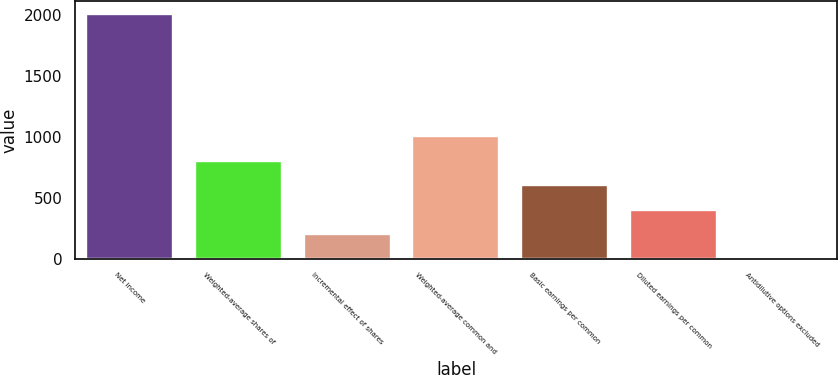Convert chart. <chart><loc_0><loc_0><loc_500><loc_500><bar_chart><fcel>Net income<fcel>Weighted-average shares of<fcel>Incremental effect of shares<fcel>Weighted-average common and<fcel>Basic earnings per common<fcel>Diluted earnings per common<fcel>Antidilutive options excluded<nl><fcel>2016<fcel>806.64<fcel>201.96<fcel>1008.2<fcel>605.08<fcel>403.52<fcel>0.4<nl></chart> 